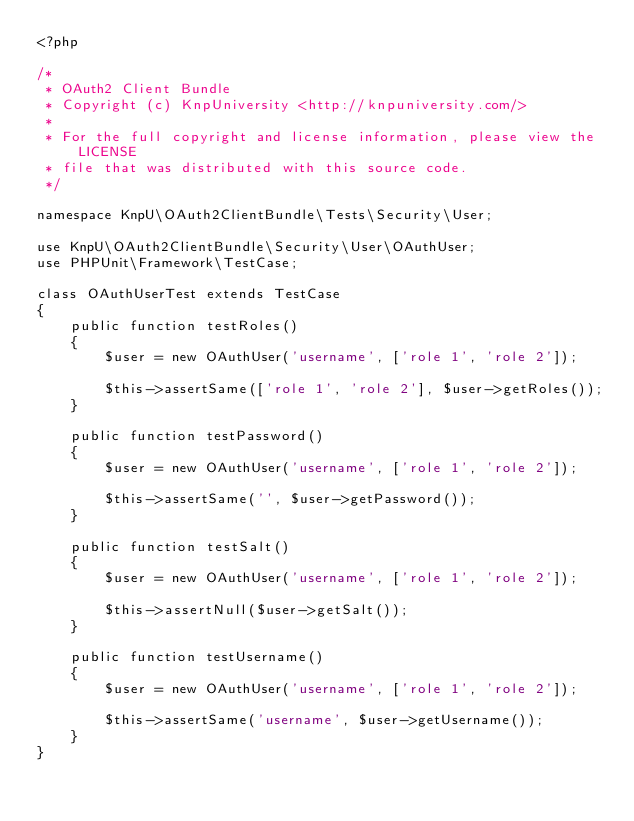<code> <loc_0><loc_0><loc_500><loc_500><_PHP_><?php

/*
 * OAuth2 Client Bundle
 * Copyright (c) KnpUniversity <http://knpuniversity.com/>
 *
 * For the full copyright and license information, please view the LICENSE
 * file that was distributed with this source code.
 */

namespace KnpU\OAuth2ClientBundle\Tests\Security\User;

use KnpU\OAuth2ClientBundle\Security\User\OAuthUser;
use PHPUnit\Framework\TestCase;

class OAuthUserTest extends TestCase
{
    public function testRoles()
    {
        $user = new OAuthUser('username', ['role 1', 'role 2']);

        $this->assertSame(['role 1', 'role 2'], $user->getRoles());
    }

    public function testPassword()
    {
        $user = new OAuthUser('username', ['role 1', 'role 2']);

        $this->assertSame('', $user->getPassword());
    }

    public function testSalt()
    {
        $user = new OAuthUser('username', ['role 1', 'role 2']);

        $this->assertNull($user->getSalt());
    }

    public function testUsername()
    {
        $user = new OAuthUser('username', ['role 1', 'role 2']);

        $this->assertSame('username', $user->getUsername());
    }
}
</code> 